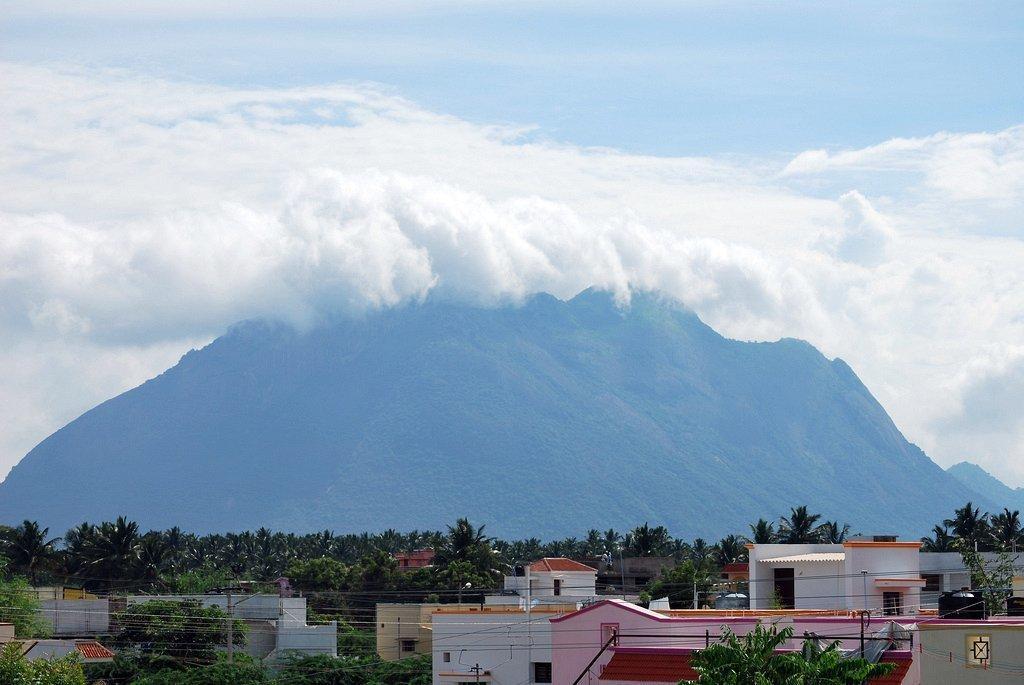How would you summarize this image in a sentence or two? At the bottom we can see building, house, street lights and many trees. In the background there is a mountain. At the top we can see sky and clouds. 